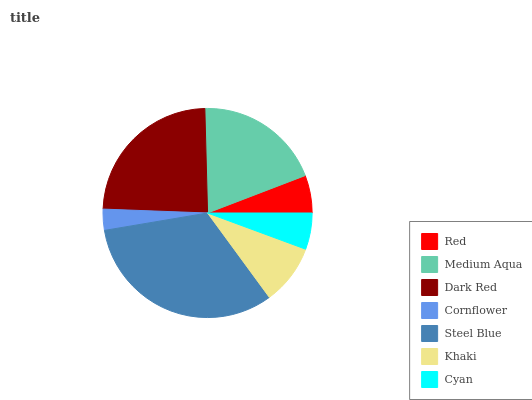Is Cornflower the minimum?
Answer yes or no. Yes. Is Steel Blue the maximum?
Answer yes or no. Yes. Is Medium Aqua the minimum?
Answer yes or no. No. Is Medium Aqua the maximum?
Answer yes or no. No. Is Medium Aqua greater than Red?
Answer yes or no. Yes. Is Red less than Medium Aqua?
Answer yes or no. Yes. Is Red greater than Medium Aqua?
Answer yes or no. No. Is Medium Aqua less than Red?
Answer yes or no. No. Is Khaki the high median?
Answer yes or no. Yes. Is Khaki the low median?
Answer yes or no. Yes. Is Dark Red the high median?
Answer yes or no. No. Is Red the low median?
Answer yes or no. No. 